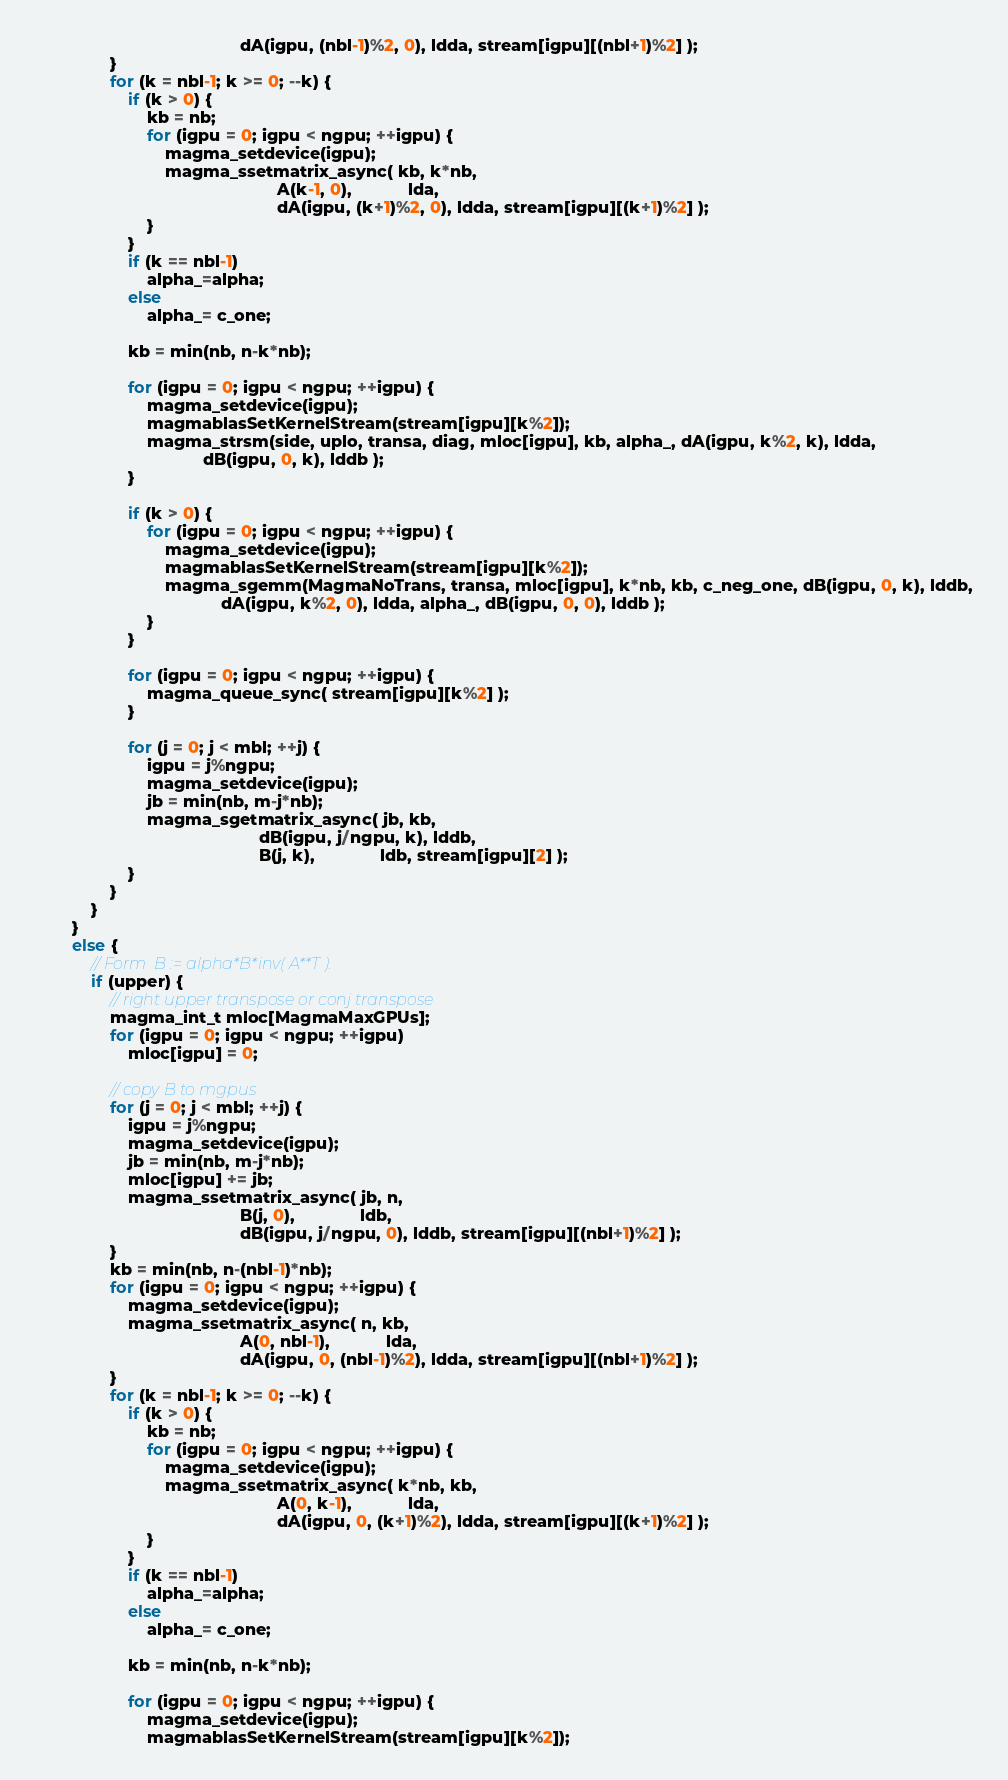<code> <loc_0><loc_0><loc_500><loc_500><_C++_>                                            dA(igpu, (nbl-1)%2, 0), ldda, stream[igpu][(nbl+1)%2] );
                }
                for (k = nbl-1; k >= 0; --k) {
                    if (k > 0) {
                        kb = nb;
                        for (igpu = 0; igpu < ngpu; ++igpu) {
                            magma_setdevice(igpu);
                            magma_ssetmatrix_async( kb, k*nb,
                                                    A(k-1, 0),            lda,
                                                    dA(igpu, (k+1)%2, 0), ldda, stream[igpu][(k+1)%2] );
                        }
                    }
                    if (k == nbl-1)
                        alpha_=alpha;
                    else
                        alpha_= c_one;

                    kb = min(nb, n-k*nb);

                    for (igpu = 0; igpu < ngpu; ++igpu) {
                        magma_setdevice(igpu);
                        magmablasSetKernelStream(stream[igpu][k%2]);
                        magma_strsm(side, uplo, transa, diag, mloc[igpu], kb, alpha_, dA(igpu, k%2, k), ldda,
                                    dB(igpu, 0, k), lddb );
                    }

                    if (k > 0) {
                        for (igpu = 0; igpu < ngpu; ++igpu) {
                            magma_setdevice(igpu);
                            magmablasSetKernelStream(stream[igpu][k%2]);
                            magma_sgemm(MagmaNoTrans, transa, mloc[igpu], k*nb, kb, c_neg_one, dB(igpu, 0, k), lddb,
                                        dA(igpu, k%2, 0), ldda, alpha_, dB(igpu, 0, 0), lddb );
                        }
                    }

                    for (igpu = 0; igpu < ngpu; ++igpu) {
                        magma_queue_sync( stream[igpu][k%2] );
                    }

                    for (j = 0; j < mbl; ++j) {
                        igpu = j%ngpu;
                        magma_setdevice(igpu);
                        jb = min(nb, m-j*nb);
                        magma_sgetmatrix_async( jb, kb,
                                                dB(igpu, j/ngpu, k), lddb,
                                                B(j, k),              ldb, stream[igpu][2] );
                    }
                }
            }
        }
        else {
            // Form  B := alpha*B*inv( A**T ).
            if (upper) {
                // right upper transpose or conj transpose
                magma_int_t mloc[MagmaMaxGPUs];
                for (igpu = 0; igpu < ngpu; ++igpu)
                    mloc[igpu] = 0;

                // copy B to mgpus
                for (j = 0; j < mbl; ++j) {
                    igpu = j%ngpu;
                    magma_setdevice(igpu);
                    jb = min(nb, m-j*nb);
                    mloc[igpu] += jb;
                    magma_ssetmatrix_async( jb, n,
                                            B(j, 0),              ldb,
                                            dB(igpu, j/ngpu, 0), lddb, stream[igpu][(nbl+1)%2] );
                }
                kb = min(nb, n-(nbl-1)*nb);
                for (igpu = 0; igpu < ngpu; ++igpu) {
                    magma_setdevice(igpu);
                    magma_ssetmatrix_async( n, kb,
                                            A(0, nbl-1),            lda,
                                            dA(igpu, 0, (nbl-1)%2), ldda, stream[igpu][(nbl+1)%2] );
                }
                for (k = nbl-1; k >= 0; --k) {
                    if (k > 0) {
                        kb = nb;
                        for (igpu = 0; igpu < ngpu; ++igpu) {
                            magma_setdevice(igpu);
                            magma_ssetmatrix_async( k*nb, kb,
                                                    A(0, k-1),            lda,
                                                    dA(igpu, 0, (k+1)%2), ldda, stream[igpu][(k+1)%2] );
                        }
                    }
                    if (k == nbl-1)
                        alpha_=alpha;
                    else
                        alpha_= c_one;

                    kb = min(nb, n-k*nb);

                    for (igpu = 0; igpu < ngpu; ++igpu) {
                        magma_setdevice(igpu);
                        magmablasSetKernelStream(stream[igpu][k%2]);</code> 